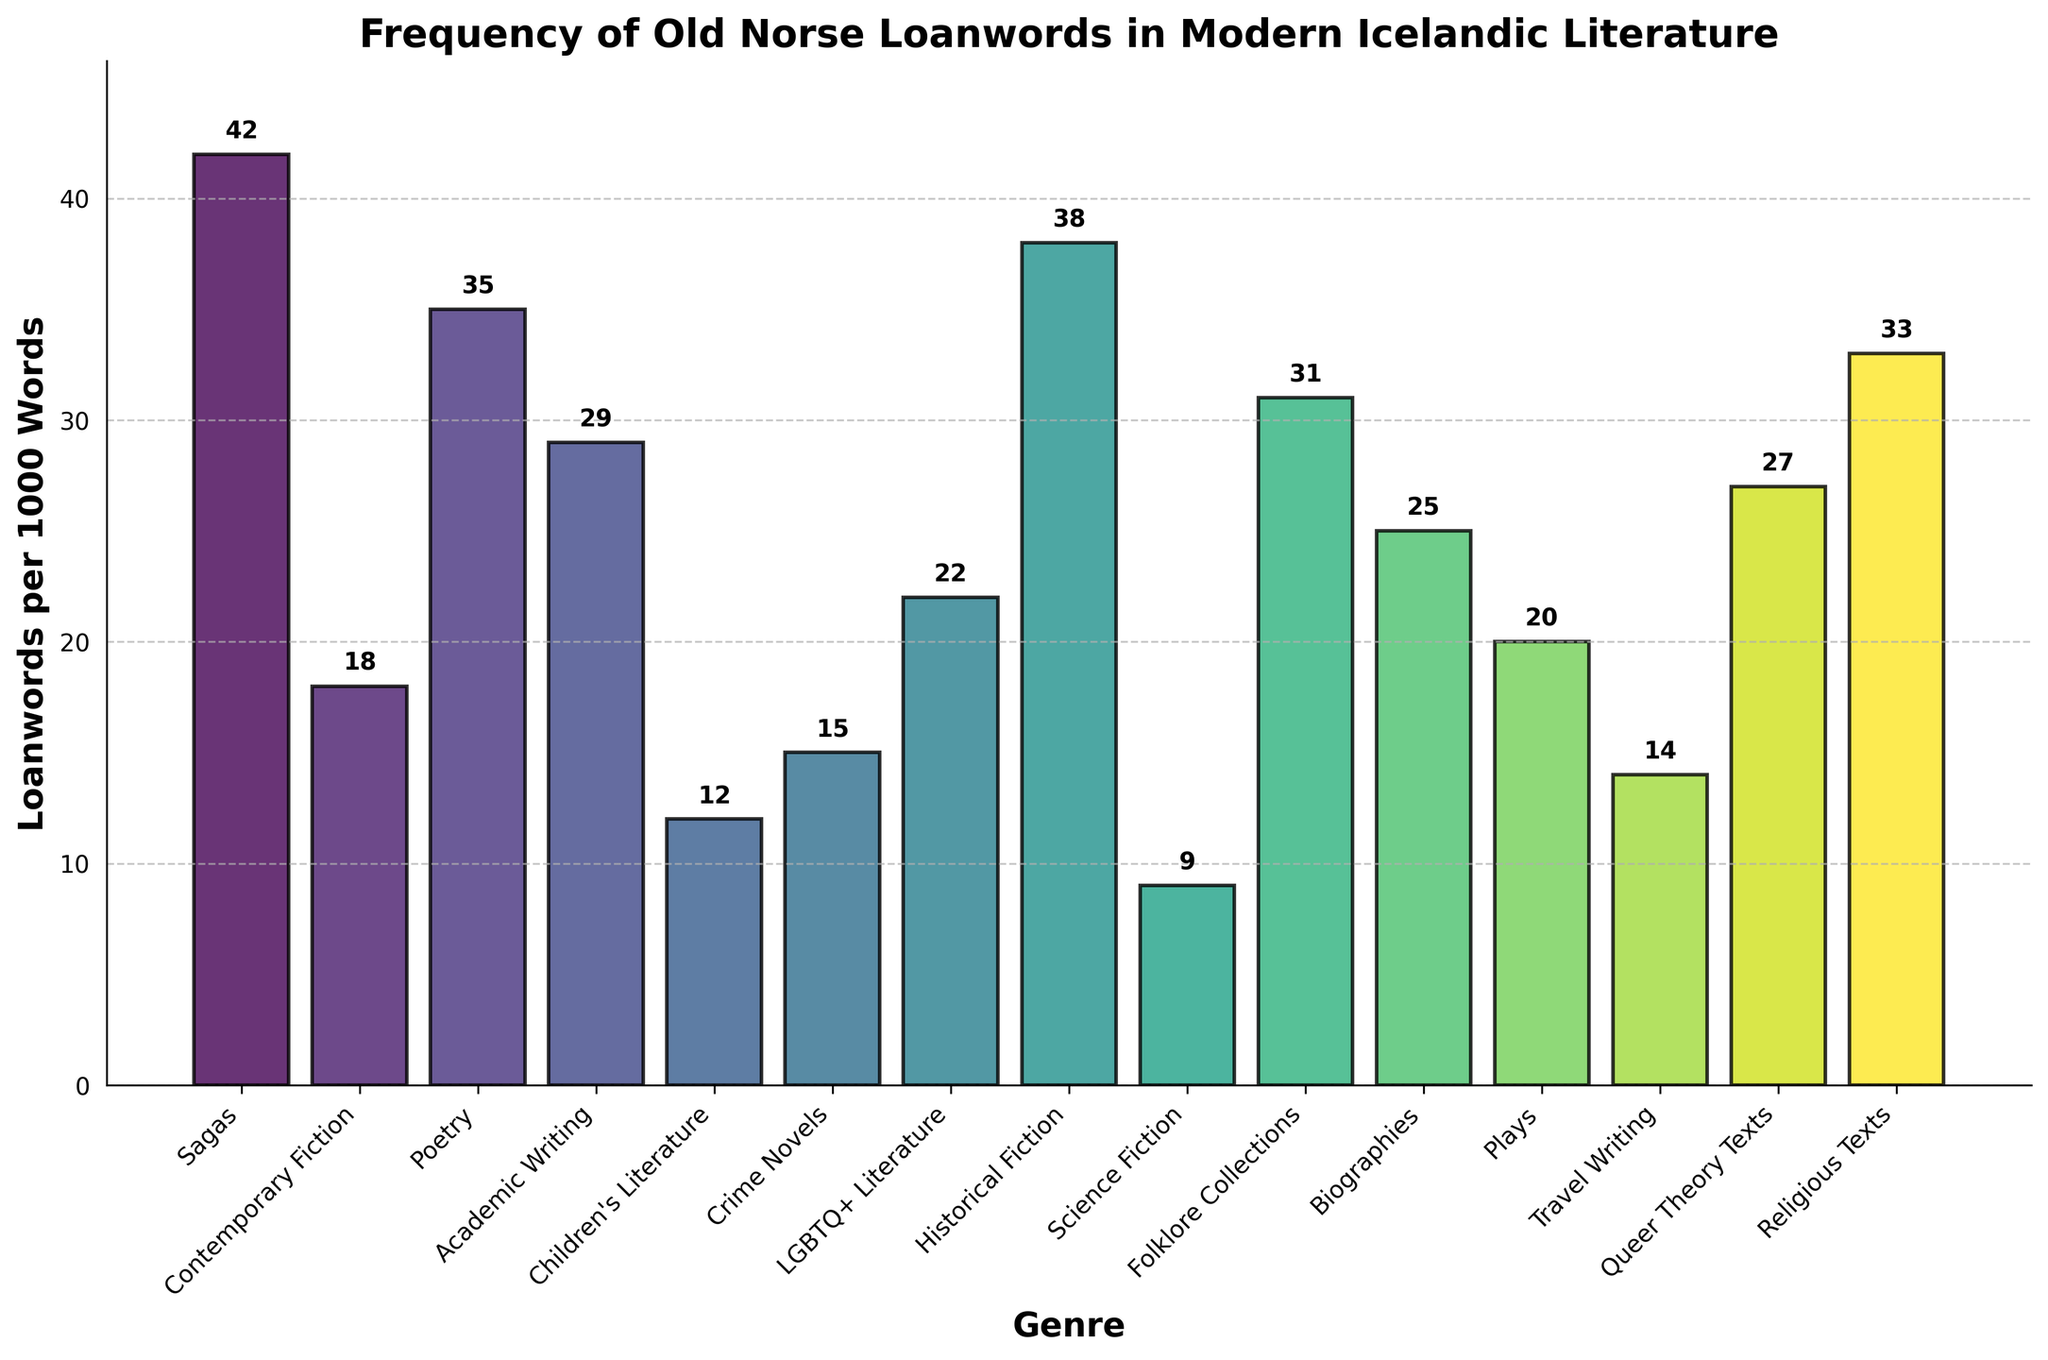What's the genre with the highest frequency of Old Norse loanwords per 1000 words? Observe the height of the bars. The highest bar corresponds to "Sagas," indicating that it has the highest frequency.
Answer: Sagas Which genre has more Old Norse loanwords per 1000 words: Children's Literature or Science Fiction? Compare the height of the two bars. The bar for Children's Literature is higher than that for Science Fiction.
Answer: Children's Literature What is the difference in the frequency of Old Norse loanwords per 1000 words between Contemporary Fiction and Historical Fiction? Locate the bars for Contemporary Fiction and Historical Fiction. The height difference is 38 - 18 = 20 loanwords per 1000 words.
Answer: 20 Which genre has the median frequency of Old Norse loanwords per 1000 words? List the frequencies in ascending order (9, 12, 14, 15, 18, 20, 22, 25, 27, 29, 31, 33, 35, 38, 42) and find the middle one. The middle value (median) is 25, corresponding to Biographies.
Answer: Biographies What is the average frequency of Old Norse loanwords per 1000 words across all genres listed? Add all the values (42 + 18 + 35 + 29 + 12 + 15 + 22 + 38 + 9 + 31 + 25 + 20 + 14 + 27 + 33 = 370) and divide by the number of genres (15). The average is 370 / 15 ≈ 24.67.
Answer: 24.67 Which genres have a frequency of Old Norse loanwords per 1000 words greater than 30? Identify bars higher than the 30-mark. Sagas (42), Poetry (35), Historical Fiction (38), Folklore Collections (31), and Religious Texts (33) all meet this criterion.
Answer: Sagas, Poetry, Historical Fiction, Folklore Collections, Religious Texts What is the combined frequency of Old Norse loanwords per 1000 words for LGBTQ+ Literature and Queer Theory Texts? Add the values for LGBTQ+ Literature (22) and Queer Theory Texts (27). The sum is 22 + 27 = 49.
Answer: 49 Which genre shows the closest frequency of Old Norse loanwords per 1000 words to Academic Writing? Look at the bar for Academic Writing (29) and compare with others. Folklore Collections has the closest frequency at 31.
Answer: Folklore Collections Are there more genres with a frequency of Old Norse loanwords per 1000 words below or above 25? Count the genres below (Science Fiction, Children's Literature, Crime Novels, Contemporary Fiction, Travel Writing, Plays, LGBTQ+ Literature: 7) and above (Academic Writing, Folklore Collections, Poetry, Religious Texts, Historical Fiction, Biographies, Sagas, Queer Theory Texts, 8). There are more genres above 25.
Answer: Above Which genres fall within the range of 20 to 30 Old Norse loanwords per 1000 words? Identify the genres with bars within this range. Plays (20), LGBTQ+ Literature (22), Biographies (25), Queer Theory Texts (27), and Academic Writing (29) all fall in this range.
Answer: Plays, LGBTQ+ Literature, Biographies, Queer Theory Texts, Academic Writing 